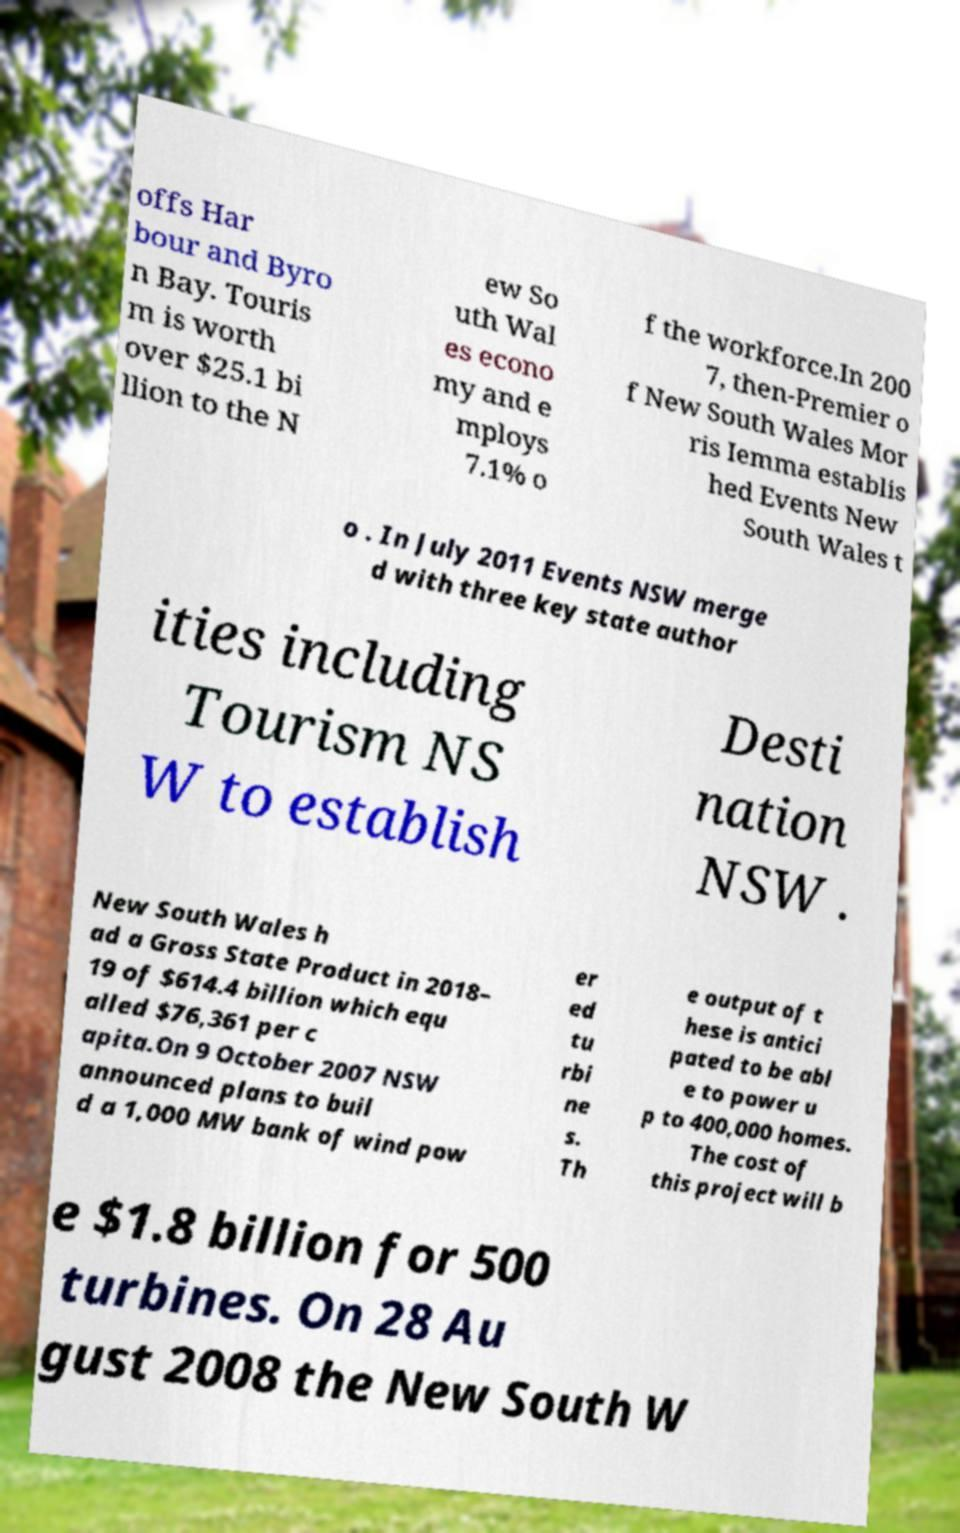For documentation purposes, I need the text within this image transcribed. Could you provide that? offs Har bour and Byro n Bay. Touris m is worth over $25.1 bi llion to the N ew So uth Wal es econo my and e mploys 7.1% o f the workforce.In 200 7, then-Premier o f New South Wales Mor ris Iemma establis hed Events New South Wales t o . In July 2011 Events NSW merge d with three key state author ities including Tourism NS W to establish Desti nation NSW . New South Wales h ad a Gross State Product in 2018– 19 of $614.4 billion which equ alled $76,361 per c apita.On 9 October 2007 NSW announced plans to buil d a 1,000 MW bank of wind pow er ed tu rbi ne s. Th e output of t hese is antici pated to be abl e to power u p to 400,000 homes. The cost of this project will b e $1.8 billion for 500 turbines. On 28 Au gust 2008 the New South W 